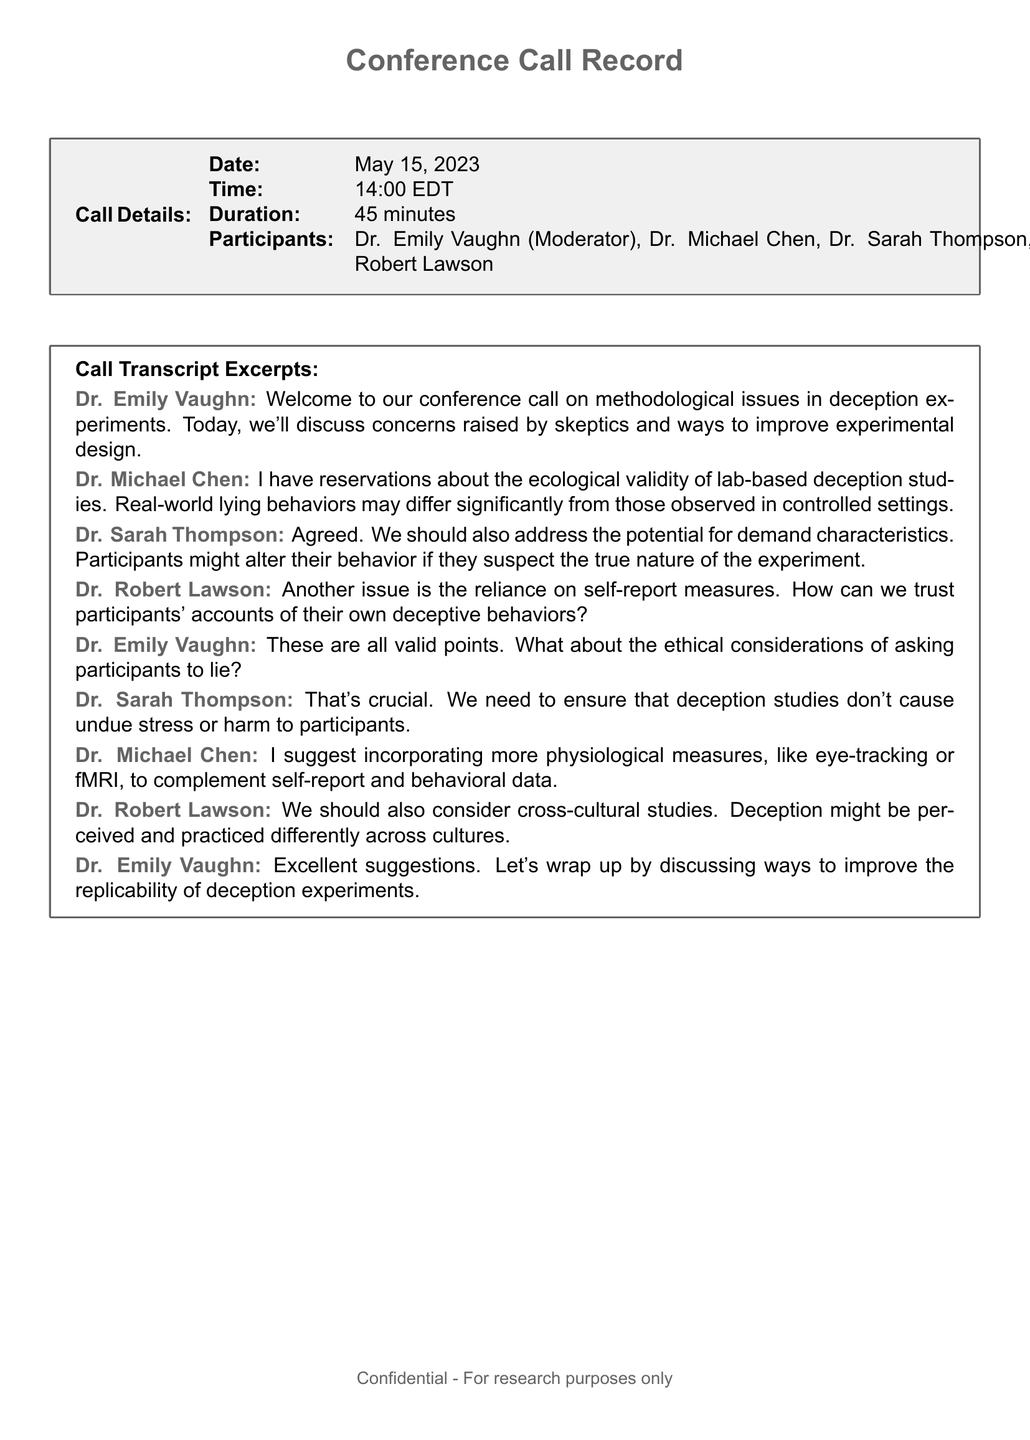What is the date of the conference call? The date is explicitly stated in the call details section of the document.
Answer: May 15, 2023 Who moderated the conference call? The moderator's name is mentioned at the beginning of the transcript.
Answer: Dr. Emily Vaughn What did Dr. Chen express reservations about? Dr. Chen's concerns are highlighted in his contribution to the discussion.
Answer: Ecological validity What ethical consideration did Dr. Vaughn mention? Dr. Vaughn raised an ethical issue during the call, specified in her statement.
Answer: Asking participants to lie Which participant suggested incorporating physiological measures? The speaker who made the suggestion is clearly identified in the transcript.
Answer: Dr. Michael Chen How long did the conference call last? The duration is provided in the call details section of the document.
Answer: 45 minutes What potential issue does Dr. Thompson raise regarding participant behavior? Dr. Thompson’s concerns are outlined in her statement about the experiment.
Answer: Demand characteristics Which participant mentioned the need for cross-cultural studies? The participant discussing this topic is explicitly noted in the transcript.
Answer: Dr. Robert Lawson 